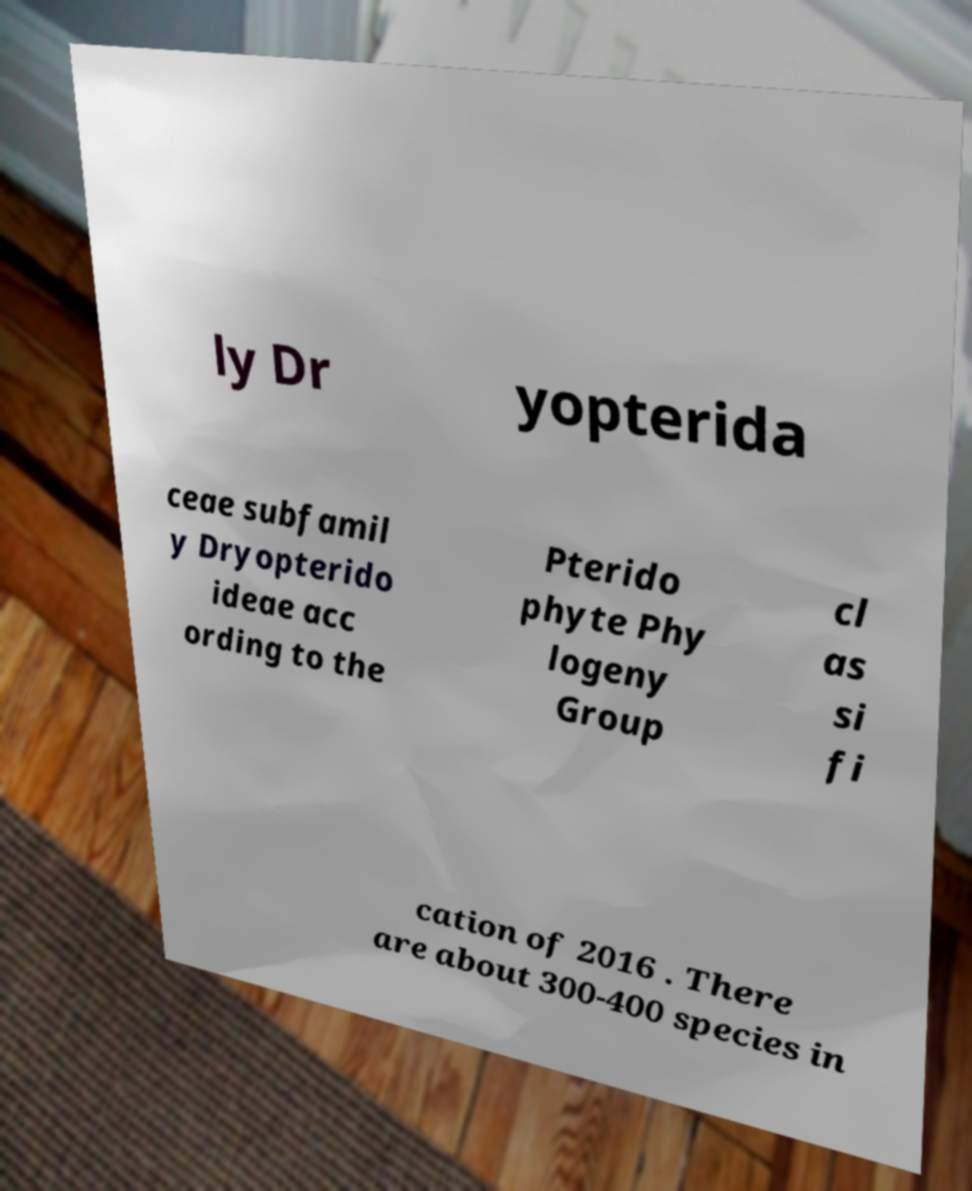For documentation purposes, I need the text within this image transcribed. Could you provide that? ly Dr yopterida ceae subfamil y Dryopterido ideae acc ording to the Pterido phyte Phy logeny Group cl as si fi cation of 2016 . There are about 300-400 species in 